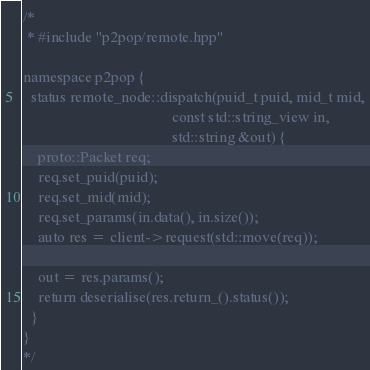<code> <loc_0><loc_0><loc_500><loc_500><_C++_>/*
 * #include "p2pop/remote.hpp"

namespace p2pop {
  status remote_node::dispatch(puid_t puid, mid_t mid,
                                       const std::string_view in,
                                       std::string &out) {
    proto::Packet req;
    req.set_puid(puid);
    req.set_mid(mid);
    req.set_params(in.data(), in.size());
    auto res = client->request(std::move(req));

    out = res.params();
    return deserialise(res.return_().status());
  }
}
*/
</code> 